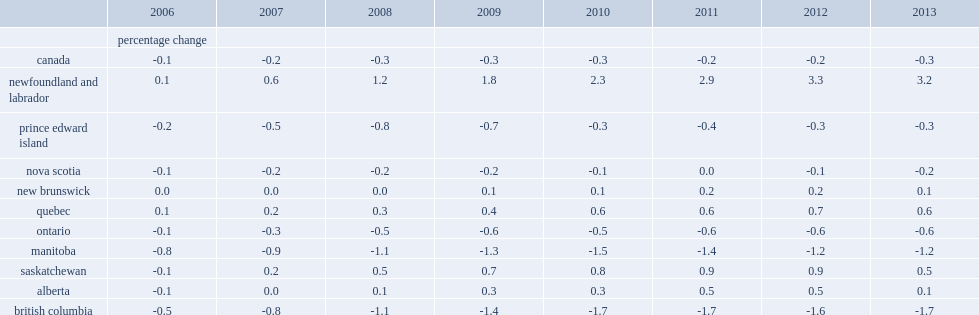At the canada level, what is the percentage difference between the revised and unrevised population in 2013? -0.3. At the provincial level, which year did manitoba experience the largest downward revisions of -1.2%? 2013.0. At the provincial level, which year did british columbia experience the largest downward revisions of -1.7%? 2013.0. At the provincial level, which year did newfoundland and labrador experience the largest upward revision of 3.2%? 2013.0. List all the provinces that experienced downward revisions for all of the years. Prince edward island ontario manitoba british columbia. List all the provinces that experienced upward revisions for each of the years. Newfoundland and labrador quebec. 